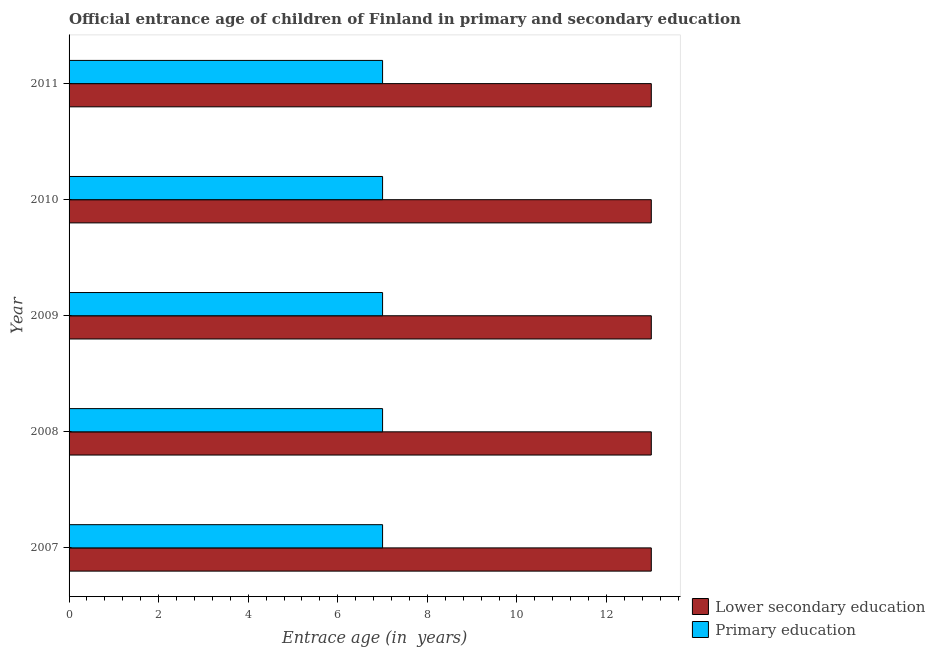How many different coloured bars are there?
Your answer should be very brief. 2. How many bars are there on the 2nd tick from the bottom?
Make the answer very short. 2. In how many cases, is the number of bars for a given year not equal to the number of legend labels?
Your answer should be very brief. 0. What is the entrance age of chiildren in primary education in 2009?
Offer a terse response. 7. Across all years, what is the maximum entrance age of chiildren in primary education?
Give a very brief answer. 7. Across all years, what is the minimum entrance age of chiildren in primary education?
Your answer should be compact. 7. What is the total entrance age of chiildren in primary education in the graph?
Provide a succinct answer. 35. What is the difference between the entrance age of chiildren in primary education in 2007 and that in 2009?
Offer a very short reply. 0. What is the difference between the entrance age of chiildren in primary education in 2009 and the entrance age of children in lower secondary education in 2007?
Ensure brevity in your answer.  -6. In the year 2009, what is the difference between the entrance age of chiildren in primary education and entrance age of children in lower secondary education?
Ensure brevity in your answer.  -6. What is the ratio of the entrance age of chiildren in primary education in 2009 to that in 2010?
Offer a very short reply. 1. Is the entrance age of chiildren in primary education in 2010 less than that in 2011?
Ensure brevity in your answer.  No. Is the difference between the entrance age of children in lower secondary education in 2007 and 2008 greater than the difference between the entrance age of chiildren in primary education in 2007 and 2008?
Keep it short and to the point. No. What is the difference between the highest and the second highest entrance age of children in lower secondary education?
Give a very brief answer. 0. What is the difference between the highest and the lowest entrance age of chiildren in primary education?
Ensure brevity in your answer.  0. In how many years, is the entrance age of children in lower secondary education greater than the average entrance age of children in lower secondary education taken over all years?
Offer a terse response. 0. Is the sum of the entrance age of children in lower secondary education in 2009 and 2011 greater than the maximum entrance age of chiildren in primary education across all years?
Provide a succinct answer. Yes. What does the 1st bar from the bottom in 2009 represents?
Make the answer very short. Lower secondary education. Are all the bars in the graph horizontal?
Offer a very short reply. Yes. What is the difference between two consecutive major ticks on the X-axis?
Keep it short and to the point. 2. Are the values on the major ticks of X-axis written in scientific E-notation?
Your answer should be very brief. No. Does the graph contain grids?
Make the answer very short. No. How many legend labels are there?
Keep it short and to the point. 2. What is the title of the graph?
Give a very brief answer. Official entrance age of children of Finland in primary and secondary education. Does "Banks" appear as one of the legend labels in the graph?
Make the answer very short. No. What is the label or title of the X-axis?
Provide a short and direct response. Entrace age (in  years). What is the Entrace age (in  years) in Lower secondary education in 2007?
Your answer should be very brief. 13. What is the Entrace age (in  years) in Primary education in 2007?
Provide a short and direct response. 7. What is the Entrace age (in  years) of Lower secondary education in 2008?
Provide a succinct answer. 13. What is the Entrace age (in  years) of Primary education in 2009?
Offer a very short reply. 7. What is the Entrace age (in  years) in Lower secondary education in 2010?
Give a very brief answer. 13. What is the Entrace age (in  years) of Primary education in 2010?
Give a very brief answer. 7. What is the Entrace age (in  years) of Lower secondary education in 2011?
Your response must be concise. 13. What is the Entrace age (in  years) of Primary education in 2011?
Your response must be concise. 7. What is the total Entrace age (in  years) of Lower secondary education in the graph?
Offer a very short reply. 65. What is the difference between the Entrace age (in  years) in Lower secondary education in 2007 and that in 2008?
Make the answer very short. 0. What is the difference between the Entrace age (in  years) in Primary education in 2007 and that in 2008?
Provide a succinct answer. 0. What is the difference between the Entrace age (in  years) in Primary education in 2007 and that in 2009?
Offer a very short reply. 0. What is the difference between the Entrace age (in  years) of Primary education in 2007 and that in 2011?
Give a very brief answer. 0. What is the difference between the Entrace age (in  years) in Primary education in 2008 and that in 2010?
Offer a terse response. 0. What is the difference between the Entrace age (in  years) of Lower secondary education in 2008 and that in 2011?
Ensure brevity in your answer.  0. What is the difference between the Entrace age (in  years) in Primary education in 2008 and that in 2011?
Make the answer very short. 0. What is the difference between the Entrace age (in  years) in Primary education in 2009 and that in 2010?
Provide a succinct answer. 0. What is the difference between the Entrace age (in  years) of Lower secondary education in 2009 and that in 2011?
Your answer should be very brief. 0. What is the difference between the Entrace age (in  years) in Lower secondary education in 2010 and that in 2011?
Give a very brief answer. 0. What is the difference between the Entrace age (in  years) of Lower secondary education in 2007 and the Entrace age (in  years) of Primary education in 2008?
Offer a very short reply. 6. What is the difference between the Entrace age (in  years) of Lower secondary education in 2008 and the Entrace age (in  years) of Primary education in 2010?
Provide a short and direct response. 6. What is the difference between the Entrace age (in  years) in Lower secondary education in 2010 and the Entrace age (in  years) in Primary education in 2011?
Provide a short and direct response. 6. What is the average Entrace age (in  years) in Primary education per year?
Your response must be concise. 7. In the year 2008, what is the difference between the Entrace age (in  years) in Lower secondary education and Entrace age (in  years) in Primary education?
Offer a very short reply. 6. In the year 2009, what is the difference between the Entrace age (in  years) of Lower secondary education and Entrace age (in  years) of Primary education?
Your answer should be very brief. 6. In the year 2010, what is the difference between the Entrace age (in  years) of Lower secondary education and Entrace age (in  years) of Primary education?
Ensure brevity in your answer.  6. In the year 2011, what is the difference between the Entrace age (in  years) in Lower secondary education and Entrace age (in  years) in Primary education?
Your answer should be very brief. 6. What is the ratio of the Entrace age (in  years) in Primary education in 2007 to that in 2010?
Keep it short and to the point. 1. What is the ratio of the Entrace age (in  years) of Primary education in 2007 to that in 2011?
Give a very brief answer. 1. What is the ratio of the Entrace age (in  years) in Lower secondary education in 2008 to that in 2009?
Offer a very short reply. 1. What is the ratio of the Entrace age (in  years) in Lower secondary education in 2008 to that in 2011?
Give a very brief answer. 1. What is the ratio of the Entrace age (in  years) of Primary education in 2008 to that in 2011?
Your answer should be compact. 1. What is the ratio of the Entrace age (in  years) in Primary education in 2009 to that in 2010?
Your response must be concise. 1. What is the ratio of the Entrace age (in  years) of Primary education in 2010 to that in 2011?
Offer a very short reply. 1. What is the difference between the highest and the lowest Entrace age (in  years) in Lower secondary education?
Provide a short and direct response. 0. What is the difference between the highest and the lowest Entrace age (in  years) in Primary education?
Provide a short and direct response. 0. 